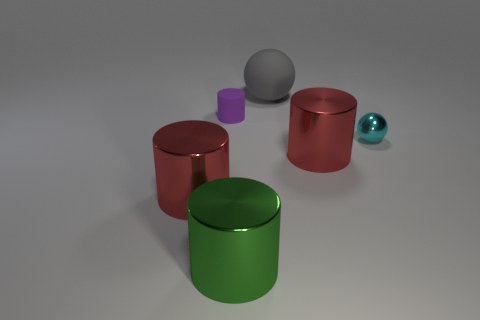Subtract all yellow balls. Subtract all brown cylinders. How many balls are left? 2 Add 2 matte cylinders. How many objects exist? 8 Subtract all balls. How many objects are left? 4 Subtract 1 cyan balls. How many objects are left? 5 Subtract all large rubber things. Subtract all large red cylinders. How many objects are left? 3 Add 5 small purple cylinders. How many small purple cylinders are left? 6 Add 5 large matte objects. How many large matte objects exist? 6 